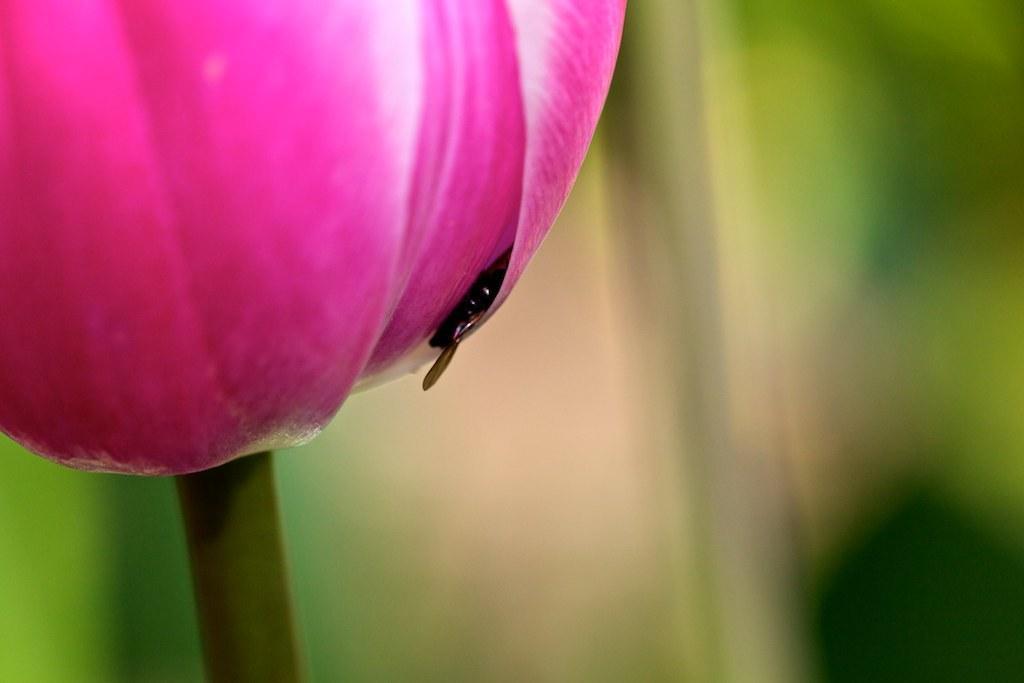Could you give a brief overview of what you see in this image? In this picture we can see a flower and insect. In the background, the image is blur. 